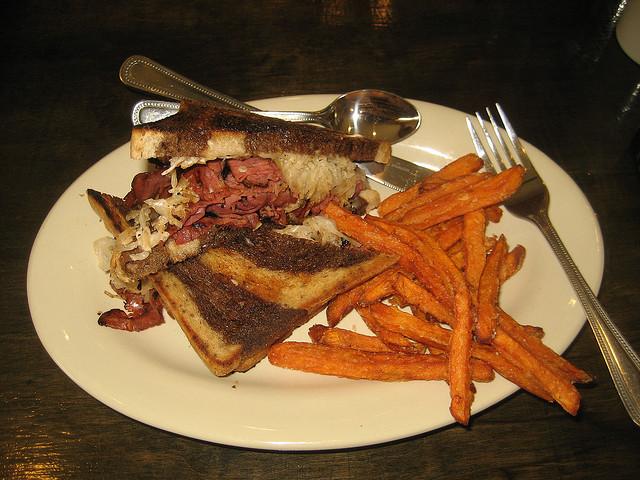What are the orange stick things?
Write a very short answer. Fries. How many pieces of silverware are present?
Write a very short answer. 3. Do you a spoon in the picture?
Be succinct. Yes. What type of fries are on the plate?
Keep it brief. Sweet potato. What is the occasion?
Be succinct. Dinner. Is there a spoon on the plate?
Give a very brief answer. Yes. Is this a good lunch for someone on a low carb diet?
Concise answer only. No. What food is to the right?
Concise answer only. Fries. Are the French fries burnt?
Keep it brief. No. 